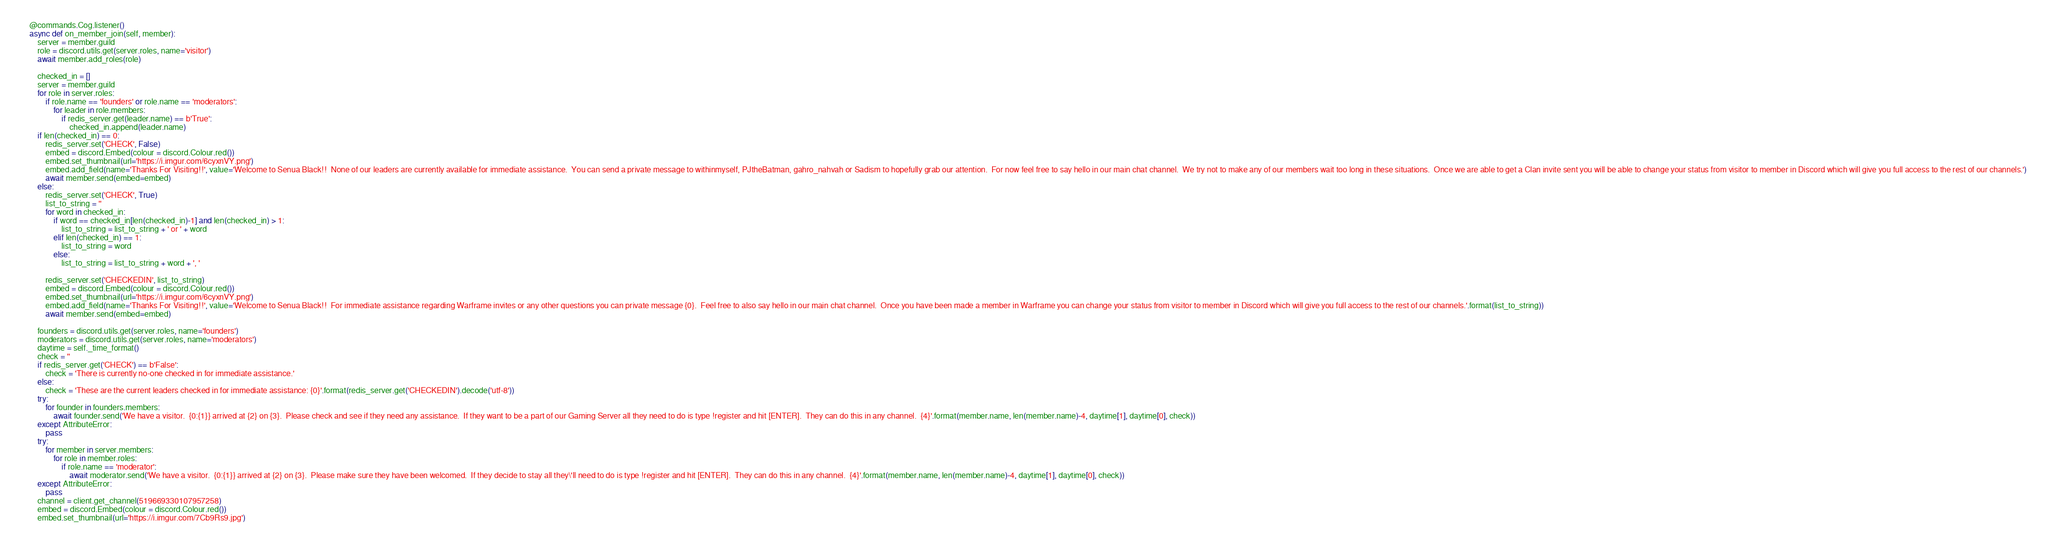<code> <loc_0><loc_0><loc_500><loc_500><_Python_>
    @commands.Cog.listener()
    async def on_member_join(self, member):
        server = member.guild
        role = discord.utils.get(server.roles, name='visitor')
        await member.add_roles(role)

        checked_in = []
        server = member.guild
        for role in server.roles:
            if role.name == 'founders' or role.name == 'moderators':
                for leader in role.members:
                    if redis_server.get(leader.name) == b'True':
                        checked_in.append(leader.name)
        if len(checked_in) == 0:
            redis_server.set('CHECK', False)
            embed = discord.Embed(colour = discord.Colour.red())
            embed.set_thumbnail(url='https://i.imgur.com/6cyxnVY.png')
            embed.add_field(name='Thanks For Visiting!!', value='Welcome to Senua Black!!  None of our leaders are currently available for immediate assistance.  You can send a private message to withinmyself, PJtheBatman, gahro_nahvah or Sadism to hopefully grab our attention.  For now feel free to say hello in our main chat channel.  We try not to make any of our members wait too long in these situations.  Once we are able to get a Clan invite sent you will be able to change your status from visitor to member in Discord which will give you full access to the rest of our channels.')
            await member.send(embed=embed)
        else:
            redis_server.set('CHECK', True)
            list_to_string = ''
            for word in checked_in:
                if word == checked_in[len(checked_in)-1] and len(checked_in) > 1:
                    list_to_string = list_to_string + ' or ' + word
                elif len(checked_in) == 1:
                    list_to_string = word
                else:
                    list_to_string = list_to_string + word + ', '

            redis_server.set('CHECKEDIN', list_to_string)
            embed = discord.Embed(colour = discord.Colour.red())
            embed.set_thumbnail(url='https://i.imgur.com/6cyxnVY.png')
            embed.add_field(name='Thanks For Visiting!!', value='Welcome to Senua Black!!  For immediate assistance regarding Warframe invites or any other questions you can private message {0}.  Feel free to also say hello in our main chat channel.  Once you have been made a member in Warframe you can change your status from visitor to member in Discord which will give you full access to the rest of our channels.'.format(list_to_string))
            await member.send(embed=embed)

        founders = discord.utils.get(server.roles, name='founders')
        moderators = discord.utils.get(server.roles, name='moderators')
        daytime = self._time_format()
        check = ''
        if redis_server.get('CHECK') == b'False':
            check = 'There is currently no-one checked in for immediate assistance.'
        else:
            check = 'These are the current leaders checked in for immediate assistance: {0}'.format(redis_server.get('CHECKEDIN').decode('utf-8'))
        try:
            for founder in founders.members:
                await founder.send('We have a visitor.  {0:{1}} arrived at {2} on {3}.  Please check and see if they need any assistance.  If they want to be a part of our Gaming Server all they need to do is type !register and hit [ENTER].  They can do this in any channel.  {4}'.format(member.name, len(member.name)-4, daytime[1], daytime[0], check))
        except AttributeError:
            pass
        try:
            for member in server.members:
                for role in member.roles:
                    if role.name == 'moderator':
                        await moderator.send('We have a visitor.  {0:{1}} arrived at {2} on {3}.  Please make sure they have been welcomed.  If they decide to stay all they\'ll need to do is type !register and hit [ENTER].  They can do this in any channel.  {4}'.format(member.name, len(member.name)-4, daytime[1], daytime[0], check))
        except AttributeError:
            pass
        channel = client.get_channel(519669330107957258)
        embed = discord.Embed(colour = discord.Colour.red())
        embed.set_thumbnail(url='https://i.imgur.com/7Cb9Rs9.jpg')</code> 